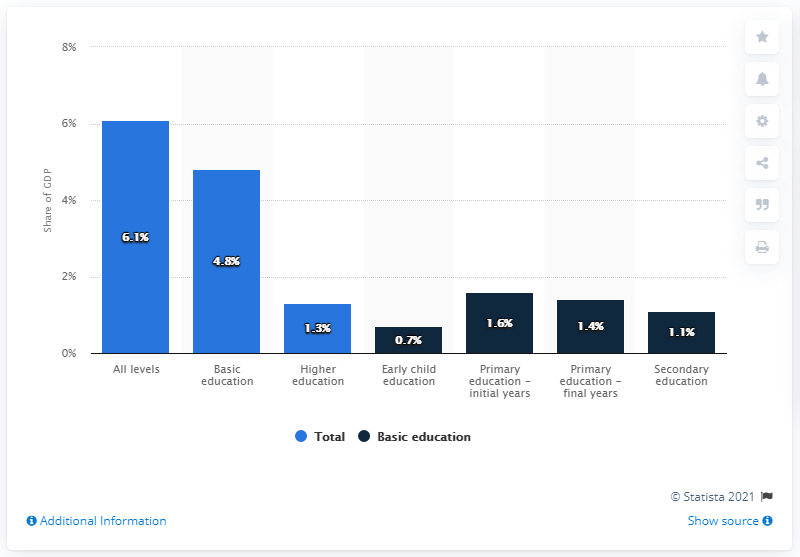Mention a couple of crucial points in this snapshot. In 2015, approximately 6.1% of Brazil's Gross Domestic Product (GDP) was allocated towards education. In 2015, approximately 6.1% of Brazil's Gross Domestic Product (GDP) was spent on education. 